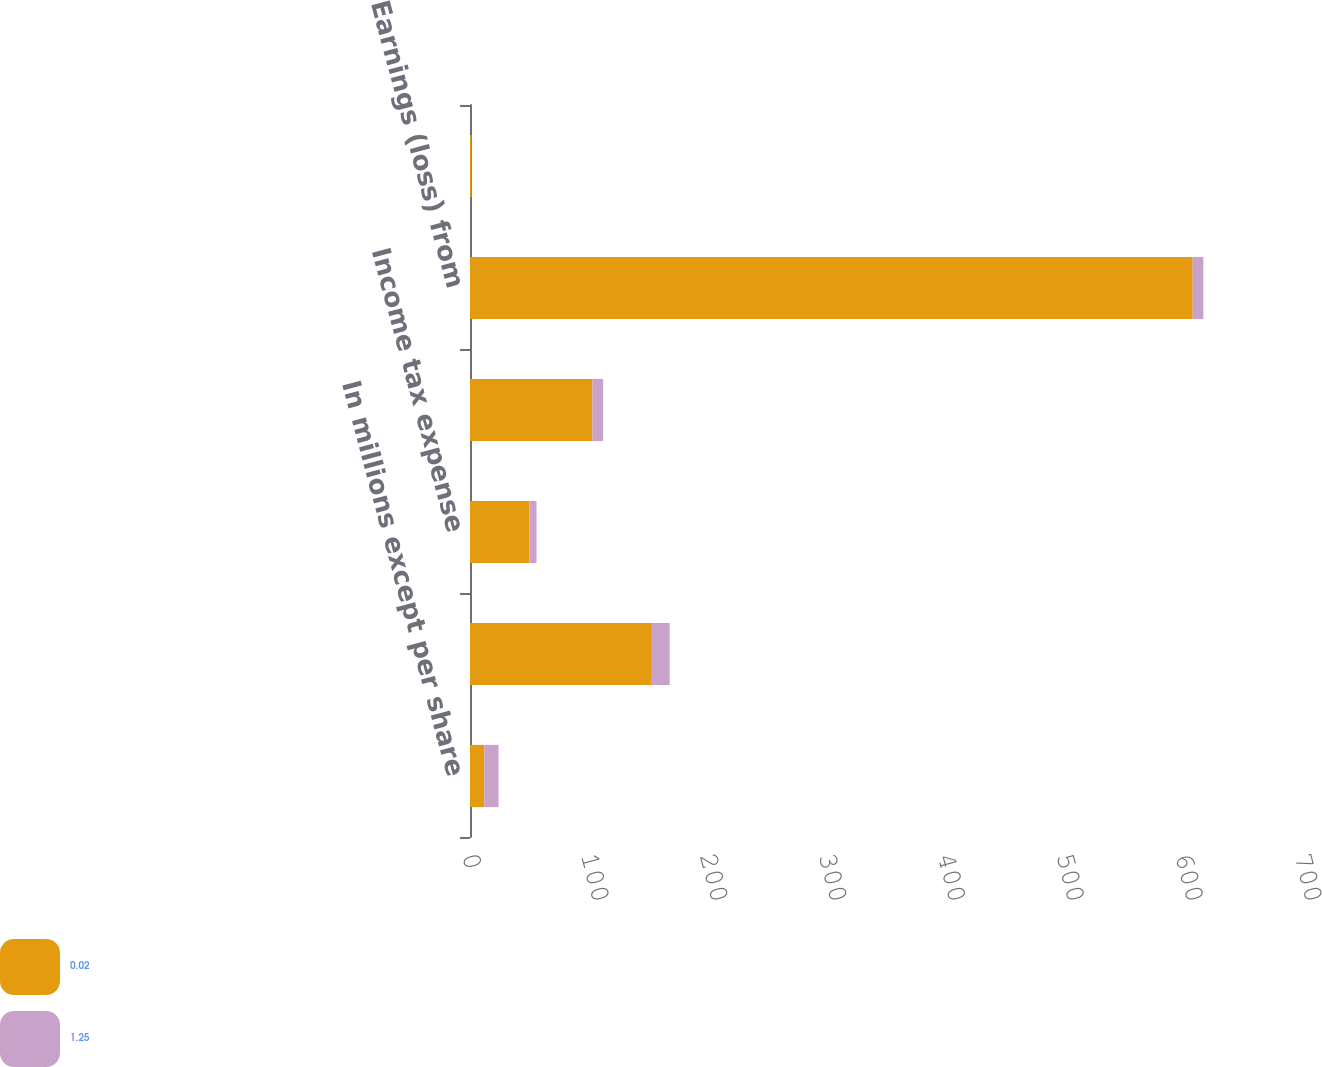Convert chart. <chart><loc_0><loc_0><loc_500><loc_500><stacked_bar_chart><ecel><fcel>In millions except per share<fcel>Earnings from operation<fcel>Income tax expense<fcel>Earnings from operation net of<fcel>Earnings (loss) from<fcel>Earnings (loss) per common<nl><fcel>0.02<fcel>12<fcel>153<fcel>50<fcel>103<fcel>608<fcel>1.25<nl><fcel>1.25<fcel>12<fcel>15<fcel>6<fcel>9<fcel>9<fcel>0.02<nl></chart> 